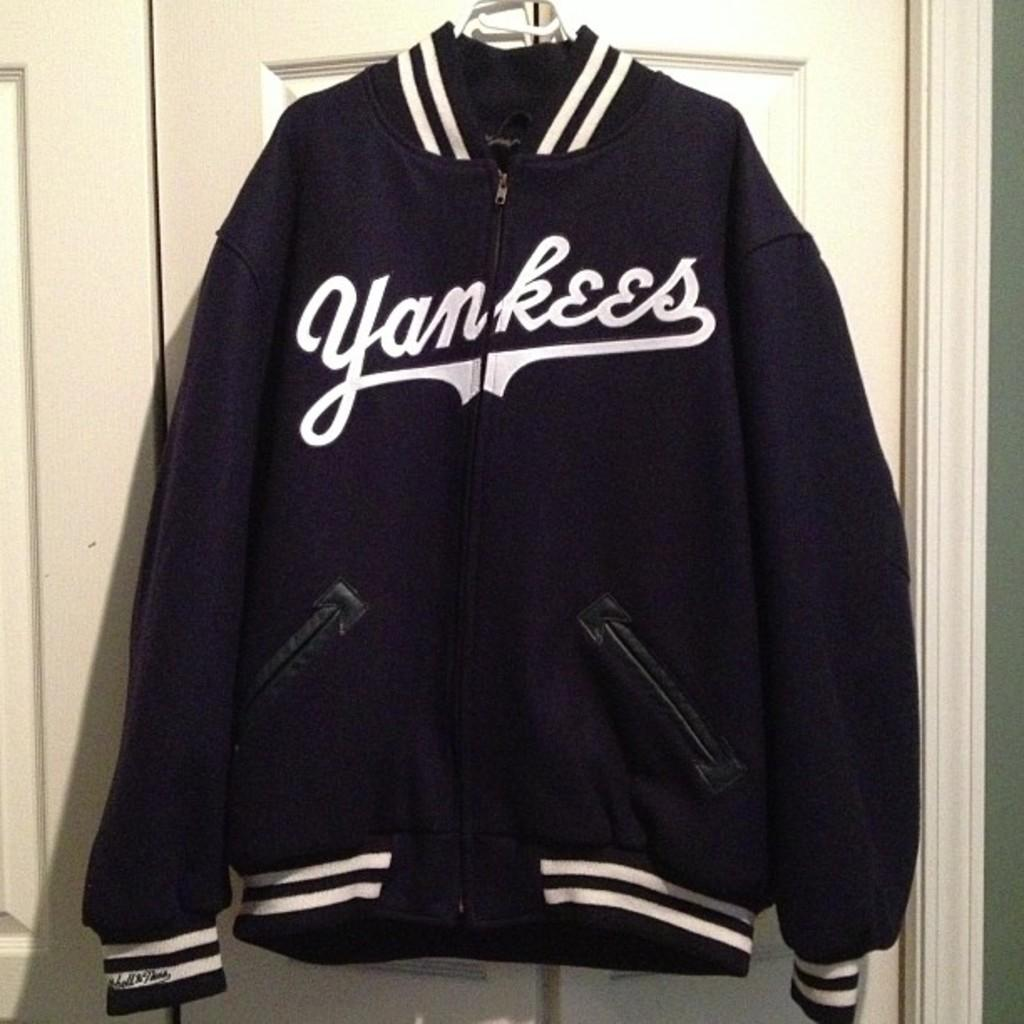<image>
Present a compact description of the photo's key features. A blue and white Yankees jacket hanging on a hanger on a door. 